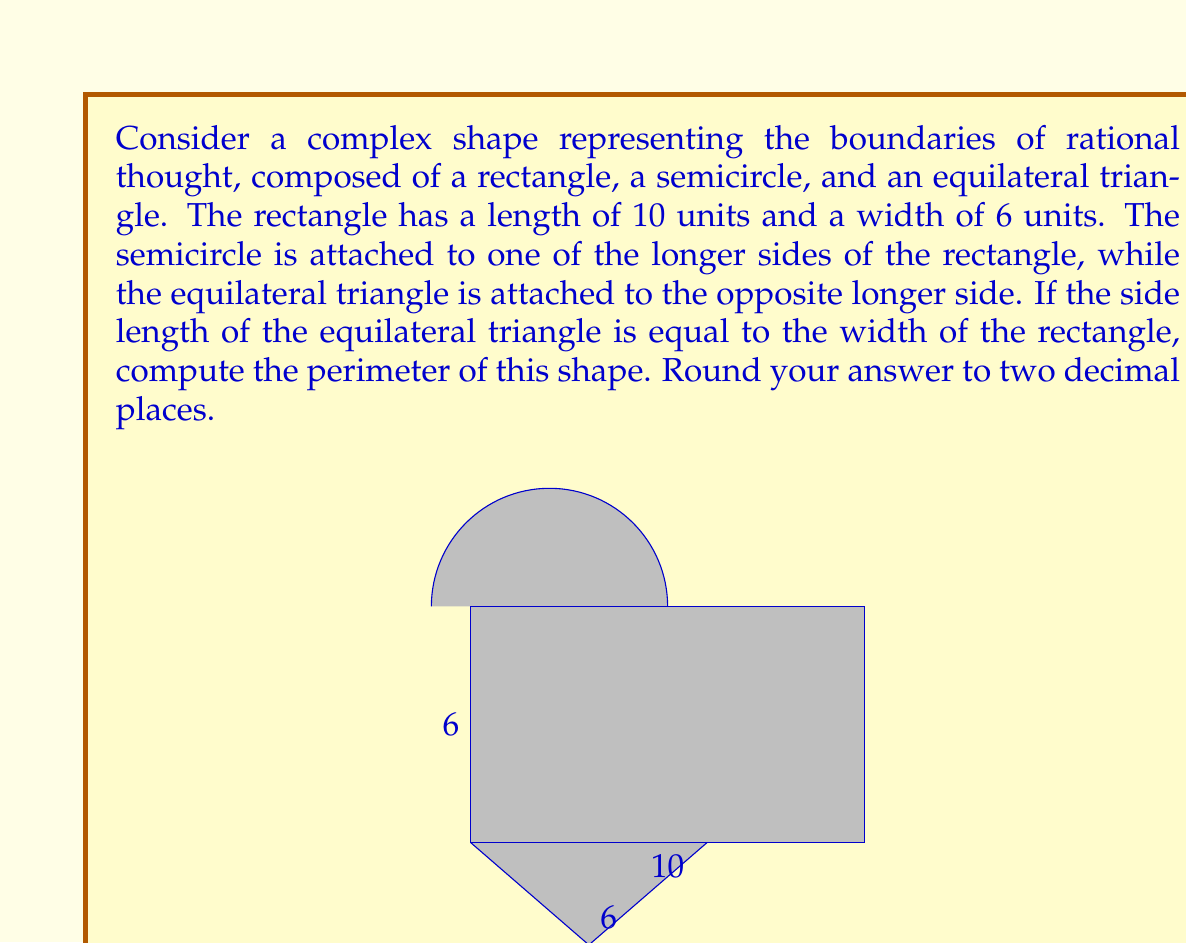Provide a solution to this math problem. Let's break this down step-by-step:

1) First, we need to calculate the perimeter of each component:

   a) Rectangle:
      Perimeter of rectangle = 2(length + width) = 2(10 + 6) = 32 units

   b) Semicircle:
      Diameter of semicircle = width of rectangle = 6 units
      Radius of semicircle = 3 units
      Arc length of semicircle = $\frac{1}{2} \cdot 2\pi r = \pi r = \pi \cdot 3 = 3\pi$ units

   c) Equilateral triangle:
      Side length = width of rectangle = 6 units
      Perimeter of triangle = 3 * 6 = 18 units

2) Now, we need to consider which parts of these shapes contribute to the overall perimeter:

   - The entire semicircle arc
   - Two sides of the equilateral triangle
   - The two shorter sides of the rectangle

3) Let's sum these up:

   Total perimeter = Arc length of semicircle + 2 sides of triangle + 2 short sides of rectangle
                   = $3\pi + 12 + 12$
                   = $3\pi + 24$ units

4) Calculating this numerically:
   $3\pi + 24 \approx 33.4248$ units

5) Rounding to two decimal places:
   33.42 units

Thus, the perimeter of the complex shape representing the boundaries of rational thought is approximately 33.42 units.
Answer: $3\pi + 24 \approx 33.42$ units 